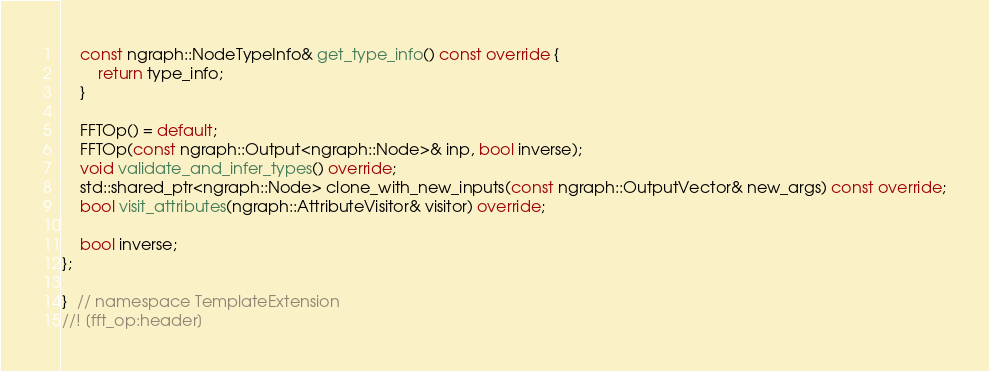Convert code to text. <code><loc_0><loc_0><loc_500><loc_500><_C++_>    const ngraph::NodeTypeInfo& get_type_info() const override {
        return type_info;
    }

    FFTOp() = default;
    FFTOp(const ngraph::Output<ngraph::Node>& inp, bool inverse);
    void validate_and_infer_types() override;
    std::shared_ptr<ngraph::Node> clone_with_new_inputs(const ngraph::OutputVector& new_args) const override;
    bool visit_attributes(ngraph::AttributeVisitor& visitor) override;

    bool inverse;
};

}  // namespace TemplateExtension
//! [fft_op:header]
</code> 